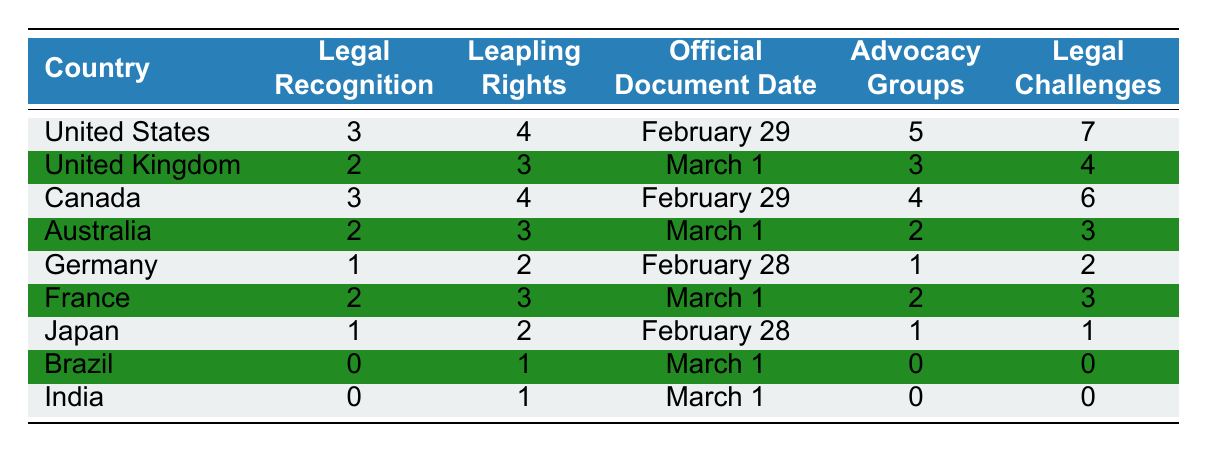What is the legal recognition status for leap day birthdays in the United States? The table states that the legal recognition for leap day birthdays in the United States is 3.
Answer: 3 Which country has the highest number of advocacy groups for leaplings? According to the table, the United States has the highest number of advocacy groups, which is 5.
Answer: 5 How many countries have legal recognition status of 0 for leap day birthdays? The table shows that Brazil and India both have a legal recognition status of 0, so there are 2 countries.
Answer: 2 What is the official document date for leap day birthdays in Canada? The table indicates that the official document date in Canada is February 29.
Answer: February 29 How many legal challenges do leaplings face in Germany compared to the United Kingdom? Germany has 2 legal challenges and the United Kingdom has 4; thus, the United Kingdom faces 2 more legal challenges than Germany.
Answer: 2 more What is the average number of leapling rights across all listed countries? The leapling rights values are 4, 3, 4, 3, 2, 3, 2, 1, and 1, which sums to 23. Dividing by the 9 countries gives an average of 23/9 ≈ 2.56.
Answer: Approximately 2.56 Does France have a higher number of legal recognition than Japan? Comparing the table, France has a legal recognition count of 2 and Japan has a count of 1, so France does have a higher number.
Answer: Yes Which country has the least legal recognition for leap day birthdays? The table shows that both Brazil and India have the least legal recognition, which is 0.
Answer: Brazil and India If we consider only the countries with legal recognition of at least 2, what is the total number of legal challenges those countries face? The countries with legal recognition of at least 2 are United States (7), United Kingdom (4), Canada (6), Australia (3), and France (3). Summing these gives 7 + 4 + 6 + 3 + 3 = 23.
Answer: 23 Which country recognizes leap day birthdays with a document date of February 28? The table indicates that Germany and Japan both recognize leap day birthdays with a document date of February 28.
Answer: Germany and Japan 